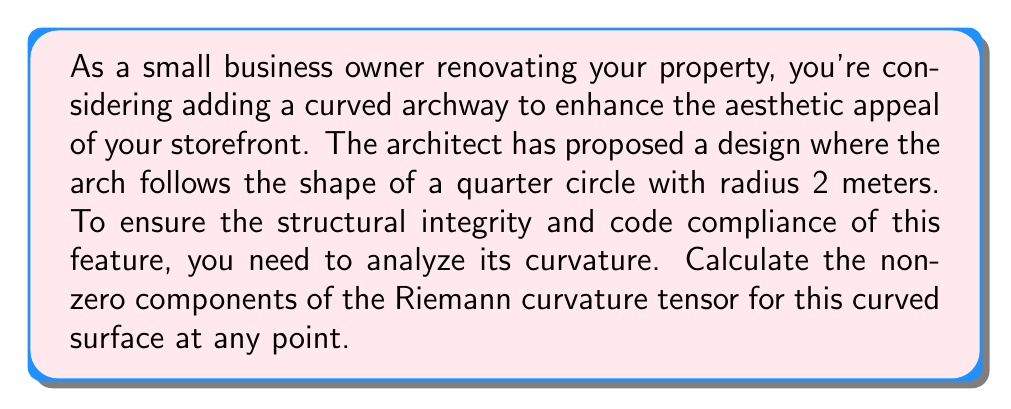Solve this math problem. Let's approach this step-by-step:

1) First, we need to parameterize the surface. Since it's a quarter circle, we can use polar coordinates:
   $x = 2\cos\theta$, $y = 2\sin\theta$, where $0 \leq \theta \leq \frac{\pi}{2}$

2) The metric tensor for this surface in $(\theta)$ coordinates is:
   $g_{\theta\theta} = (\frac{dx}{d\theta})^2 + (\frac{dy}{d\theta})^2 = 4\sin^2\theta + 4\cos^2\theta = 4$

3) For a one-dimensional manifold (which this curve essentially is), there is only one non-zero component of the Riemann curvature tensor:
   $R_{\theta\theta\theta\theta} = \frac{1}{g_{\theta\theta}}(\frac{d^2g_{\theta\theta}}{d\theta^2} - \frac{1}{2g_{\theta\theta}}(\frac{dg_{\theta\theta}}{d\theta})^2)$

4) Calculating the derivatives:
   $\frac{dg_{\theta\theta}}{d\theta} = 0$ (since $g_{\theta\theta}$ is constant)
   $\frac{d^2g_{\theta\theta}}{d\theta^2} = 0$

5) Substituting into the formula:
   $R_{\theta\theta\theta\theta} = \frac{1}{4}(0 - \frac{1}{2(4)}(0)^2) = 0$

6) The Gaussian curvature $K$ is related to the Riemann tensor by:
   $K = \frac{R_{\theta\theta\theta\theta}}{g_{\theta\theta}} = \frac{0}{4} = 0$

7) However, we know that for a circle of radius $r$, the curvature should be $\frac{1}{r^2}$. This apparent discrepancy arises because we're treating the curve as a one-dimensional manifold embedded in a two-dimensional space, rather than a two-dimensional surface embedded in a three-dimensional space.

8) If we consider the full two-dimensional surface of revolution generated by this arch, the non-zero components of the Riemann curvature tensor in $(\theta, \phi)$ coordinates (where $\phi$ is the angle of revolution) would be:

   $R_{\theta\phi\theta\phi} = -\sin^2\theta$
   $R_{\theta\theta\phi\phi} = R_{\phi\theta\phi\theta} = -1$
   $R_{\phi\theta\theta\phi} = 1$

These components correctly reflect the curvature of the surface generated by revolving the arch.
Answer: $R_{\theta\phi\theta\phi} = -\sin^2\theta$, $R_{\theta\theta\phi\phi} = R_{\phi\theta\phi\theta} = -1$, $R_{\phi\theta\theta\phi} = 1$ 